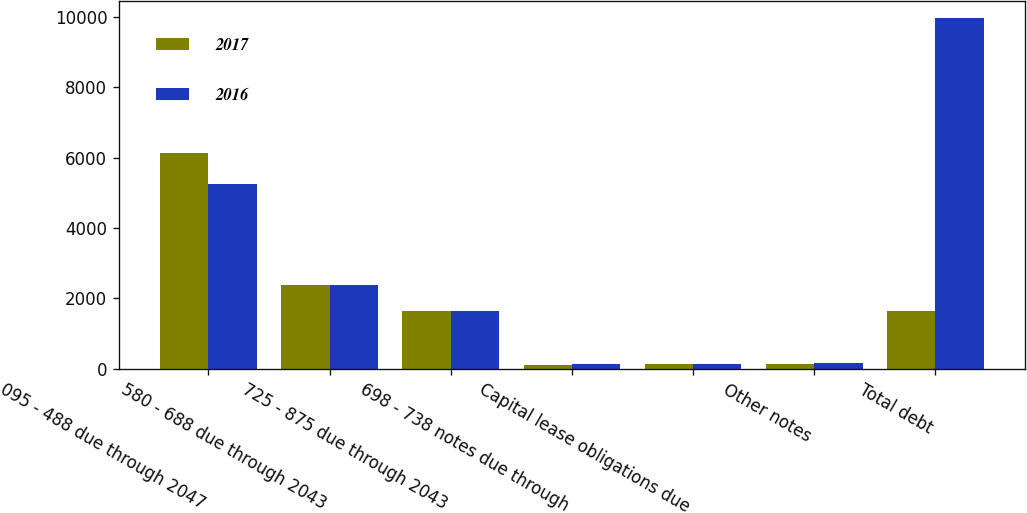Convert chart. <chart><loc_0><loc_0><loc_500><loc_500><stacked_bar_chart><ecel><fcel>095 - 488 due through 2047<fcel>580 - 688 due through 2043<fcel>725 - 875 due through 2043<fcel>698 - 738 notes due through<fcel>Capital lease obligations due<fcel>Other notes<fcel>Total debt<nl><fcel>2017<fcel>6127<fcel>2386<fcel>1637<fcel>94<fcel>138<fcel>135<fcel>1637<nl><fcel>2016<fcel>5250<fcel>2383<fcel>1641<fcel>127<fcel>138<fcel>163<fcel>9952<nl></chart> 